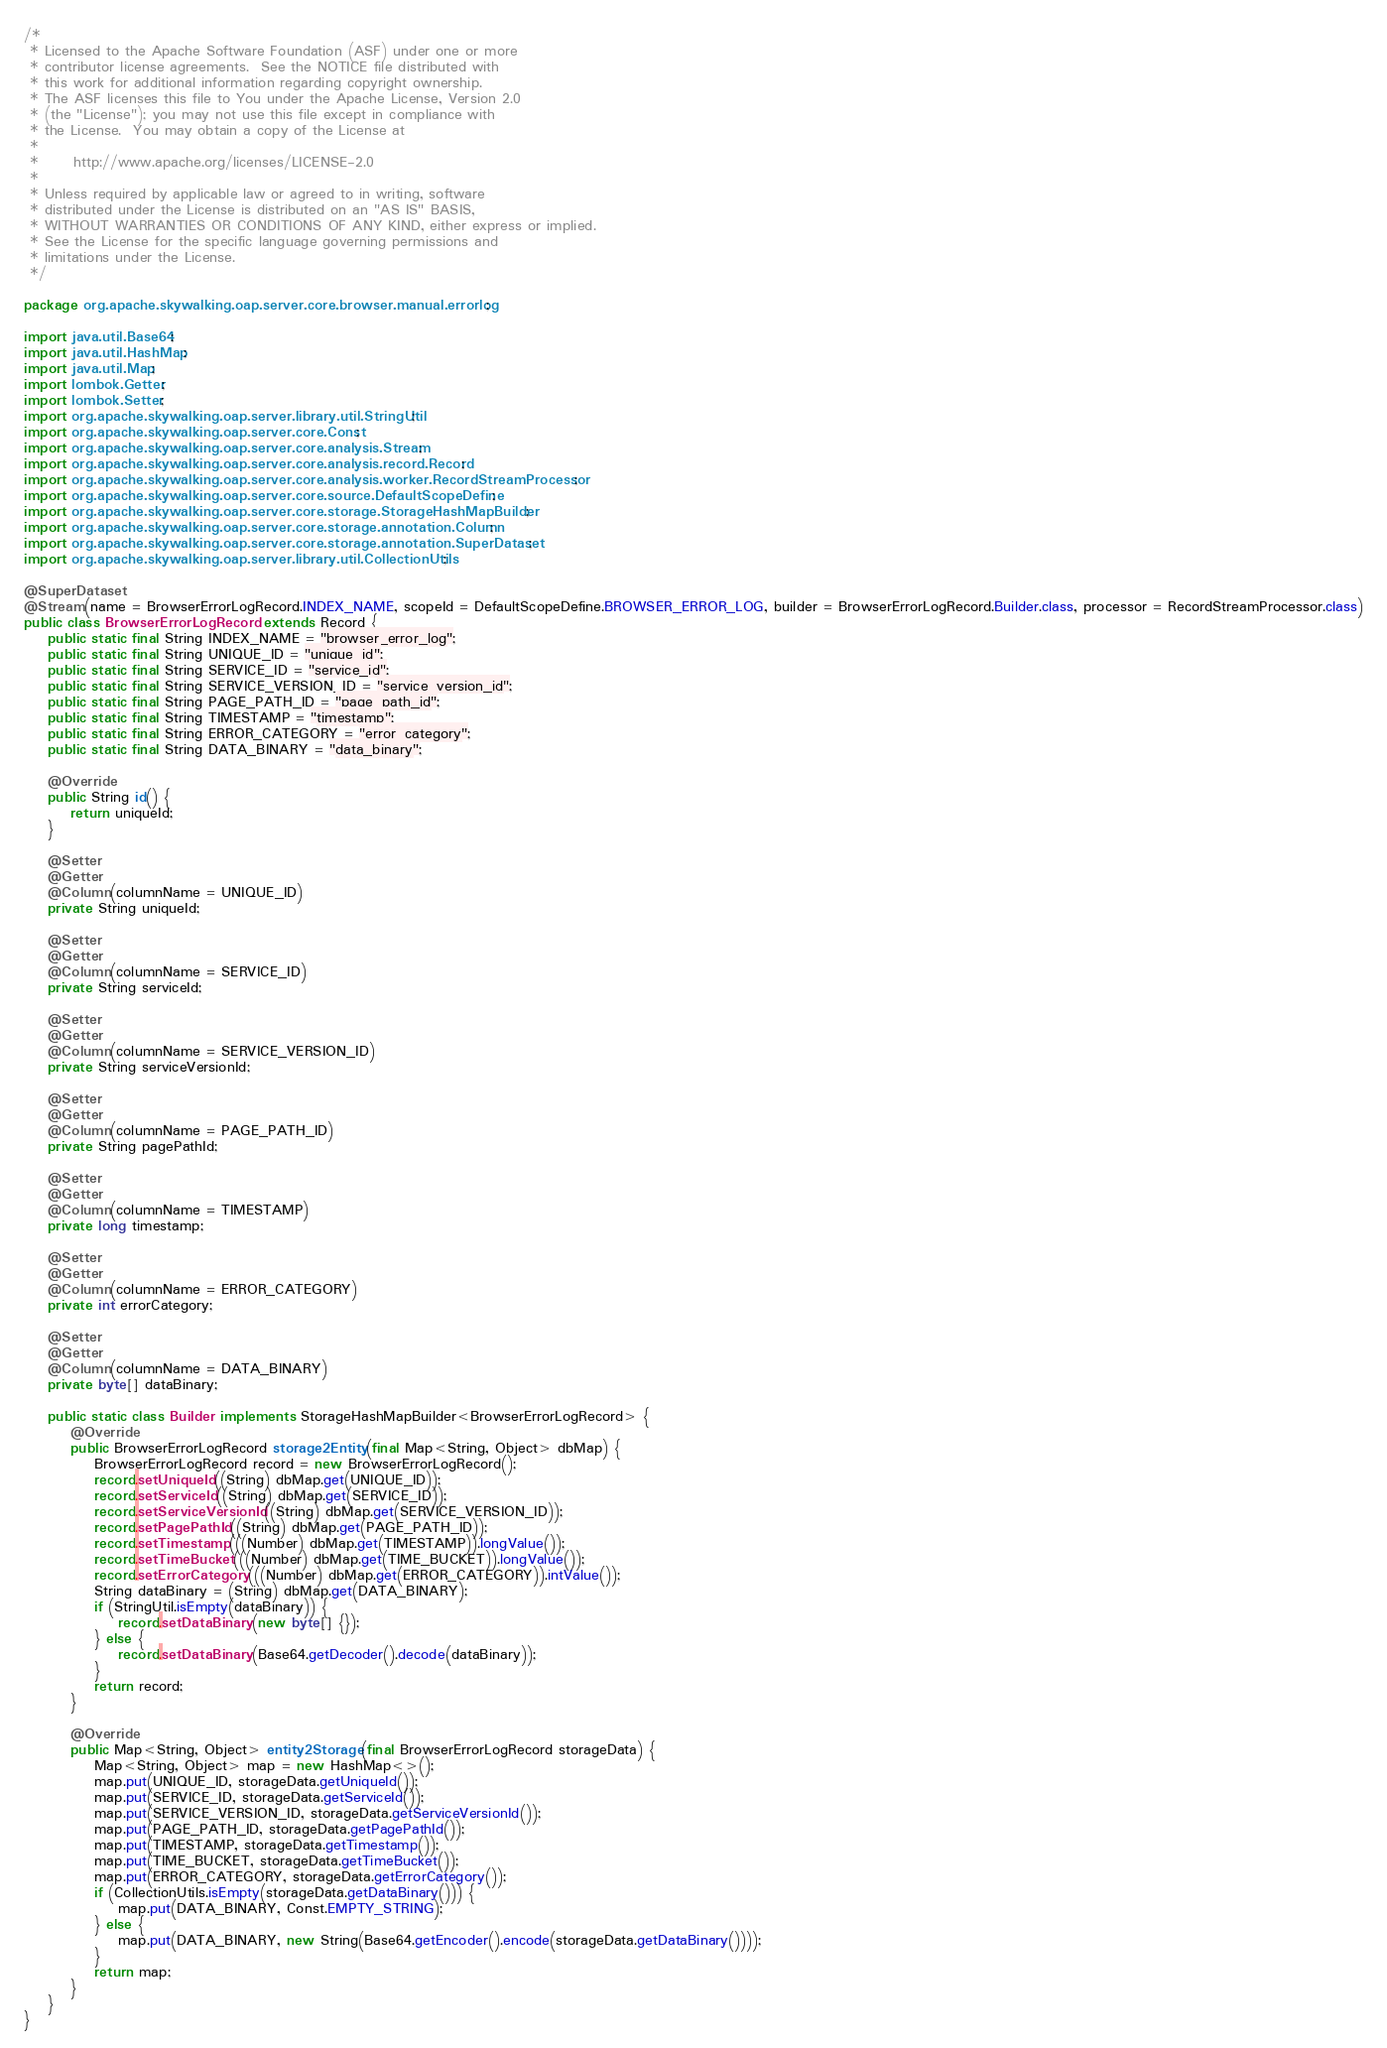Convert code to text. <code><loc_0><loc_0><loc_500><loc_500><_Java_>/*
 * Licensed to the Apache Software Foundation (ASF) under one or more
 * contributor license agreements.  See the NOTICE file distributed with
 * this work for additional information regarding copyright ownership.
 * The ASF licenses this file to You under the Apache License, Version 2.0
 * (the "License"); you may not use this file except in compliance with
 * the License.  You may obtain a copy of the License at
 *
 *      http://www.apache.org/licenses/LICENSE-2.0
 *
 * Unless required by applicable law or agreed to in writing, software
 * distributed under the License is distributed on an "AS IS" BASIS,
 * WITHOUT WARRANTIES OR CONDITIONS OF ANY KIND, either express or implied.
 * See the License for the specific language governing permissions and
 * limitations under the License.
 */

package org.apache.skywalking.oap.server.core.browser.manual.errorlog;

import java.util.Base64;
import java.util.HashMap;
import java.util.Map;
import lombok.Getter;
import lombok.Setter;
import org.apache.skywalking.oap.server.library.util.StringUtil;
import org.apache.skywalking.oap.server.core.Const;
import org.apache.skywalking.oap.server.core.analysis.Stream;
import org.apache.skywalking.oap.server.core.analysis.record.Record;
import org.apache.skywalking.oap.server.core.analysis.worker.RecordStreamProcessor;
import org.apache.skywalking.oap.server.core.source.DefaultScopeDefine;
import org.apache.skywalking.oap.server.core.storage.StorageHashMapBuilder;
import org.apache.skywalking.oap.server.core.storage.annotation.Column;
import org.apache.skywalking.oap.server.core.storage.annotation.SuperDataset;
import org.apache.skywalking.oap.server.library.util.CollectionUtils;

@SuperDataset
@Stream(name = BrowserErrorLogRecord.INDEX_NAME, scopeId = DefaultScopeDefine.BROWSER_ERROR_LOG, builder = BrowserErrorLogRecord.Builder.class, processor = RecordStreamProcessor.class)
public class BrowserErrorLogRecord extends Record {
    public static final String INDEX_NAME = "browser_error_log";
    public static final String UNIQUE_ID = "unique_id";
    public static final String SERVICE_ID = "service_id";
    public static final String SERVICE_VERSION_ID = "service_version_id";
    public static final String PAGE_PATH_ID = "page_path_id";
    public static final String TIMESTAMP = "timestamp";
    public static final String ERROR_CATEGORY = "error_category";
    public static final String DATA_BINARY = "data_binary";

    @Override
    public String id() {
        return uniqueId;
    }

    @Setter
    @Getter
    @Column(columnName = UNIQUE_ID)
    private String uniqueId;

    @Setter
    @Getter
    @Column(columnName = SERVICE_ID)
    private String serviceId;

    @Setter
    @Getter
    @Column(columnName = SERVICE_VERSION_ID)
    private String serviceVersionId;

    @Setter
    @Getter
    @Column(columnName = PAGE_PATH_ID)
    private String pagePathId;

    @Setter
    @Getter
    @Column(columnName = TIMESTAMP)
    private long timestamp;

    @Setter
    @Getter
    @Column(columnName = ERROR_CATEGORY)
    private int errorCategory;

    @Setter
    @Getter
    @Column(columnName = DATA_BINARY)
    private byte[] dataBinary;

    public static class Builder implements StorageHashMapBuilder<BrowserErrorLogRecord> {
        @Override
        public BrowserErrorLogRecord storage2Entity(final Map<String, Object> dbMap) {
            BrowserErrorLogRecord record = new BrowserErrorLogRecord();
            record.setUniqueId((String) dbMap.get(UNIQUE_ID));
            record.setServiceId((String) dbMap.get(SERVICE_ID));
            record.setServiceVersionId((String) dbMap.get(SERVICE_VERSION_ID));
            record.setPagePathId((String) dbMap.get(PAGE_PATH_ID));
            record.setTimestamp(((Number) dbMap.get(TIMESTAMP)).longValue());
            record.setTimeBucket(((Number) dbMap.get(TIME_BUCKET)).longValue());
            record.setErrorCategory(((Number) dbMap.get(ERROR_CATEGORY)).intValue());
            String dataBinary = (String) dbMap.get(DATA_BINARY);
            if (StringUtil.isEmpty(dataBinary)) {
                record.setDataBinary(new byte[] {});
            } else {
                record.setDataBinary(Base64.getDecoder().decode(dataBinary));
            }
            return record;
        }

        @Override
        public Map<String, Object> entity2Storage(final BrowserErrorLogRecord storageData) {
            Map<String, Object> map = new HashMap<>();
            map.put(UNIQUE_ID, storageData.getUniqueId());
            map.put(SERVICE_ID, storageData.getServiceId());
            map.put(SERVICE_VERSION_ID, storageData.getServiceVersionId());
            map.put(PAGE_PATH_ID, storageData.getPagePathId());
            map.put(TIMESTAMP, storageData.getTimestamp());
            map.put(TIME_BUCKET, storageData.getTimeBucket());
            map.put(ERROR_CATEGORY, storageData.getErrorCategory());
            if (CollectionUtils.isEmpty(storageData.getDataBinary())) {
                map.put(DATA_BINARY, Const.EMPTY_STRING);
            } else {
                map.put(DATA_BINARY, new String(Base64.getEncoder().encode(storageData.getDataBinary())));
            }
            return map;
        }
    }
}
</code> 